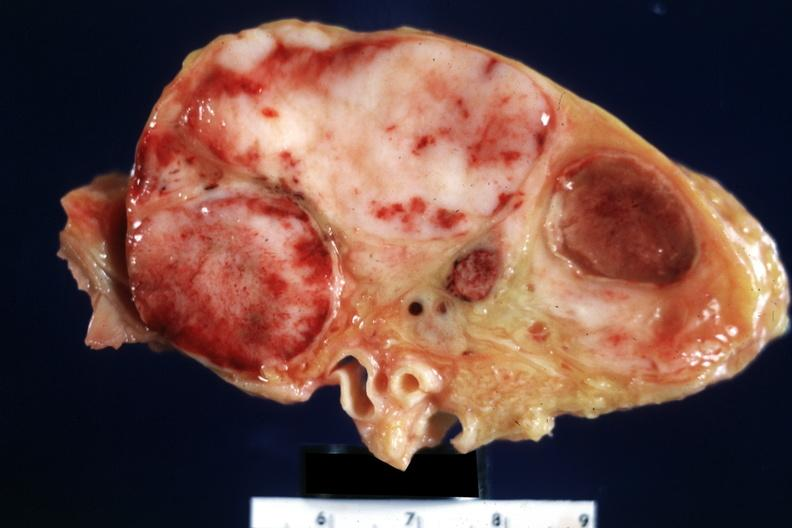what is present?
Answer the question using a single word or phrase. Malignant lymphoma 